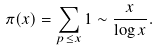<formula> <loc_0><loc_0><loc_500><loc_500>\pi ( x ) = \sum _ { p \leq x } 1 \sim \frac { x } { \log x } .</formula> 